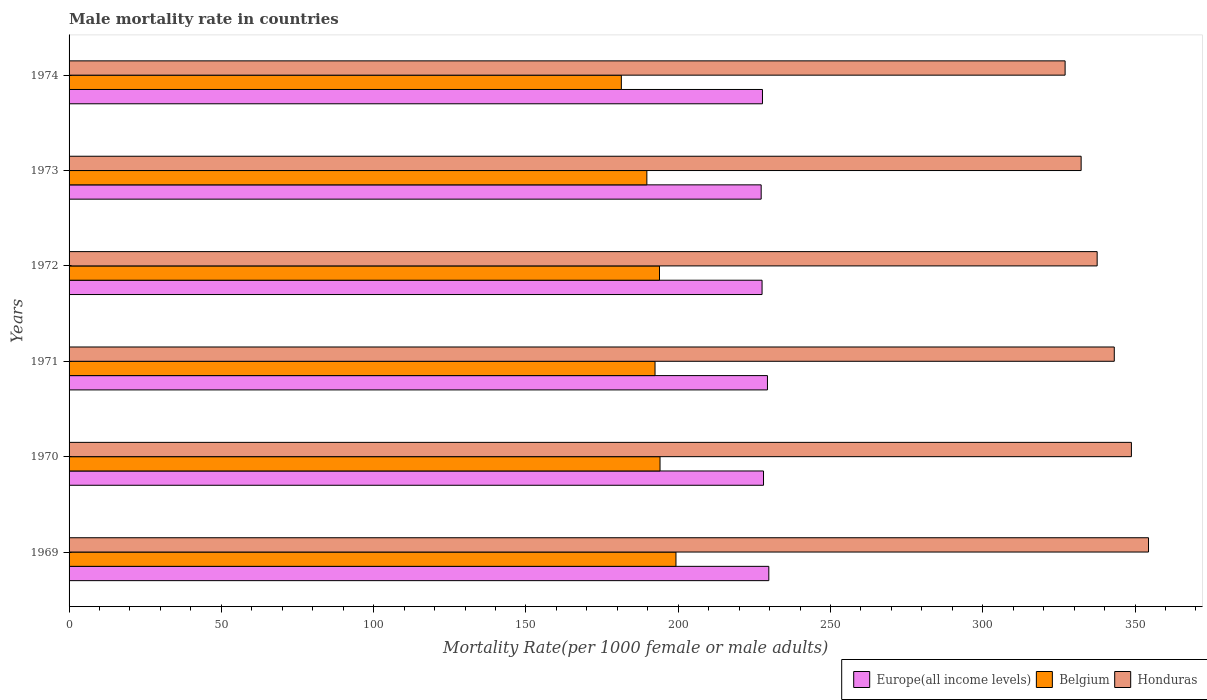How many different coloured bars are there?
Provide a succinct answer. 3. How many groups of bars are there?
Offer a terse response. 6. Are the number of bars per tick equal to the number of legend labels?
Keep it short and to the point. Yes. How many bars are there on the 6th tick from the top?
Your answer should be very brief. 3. What is the label of the 6th group of bars from the top?
Your answer should be very brief. 1969. What is the male mortality rate in Europe(all income levels) in 1969?
Provide a short and direct response. 229.76. Across all years, what is the maximum male mortality rate in Belgium?
Ensure brevity in your answer.  199.27. Across all years, what is the minimum male mortality rate in Honduras?
Provide a succinct answer. 327.04. In which year was the male mortality rate in Honduras maximum?
Ensure brevity in your answer.  1969. In which year was the male mortality rate in Europe(all income levels) minimum?
Your response must be concise. 1973. What is the total male mortality rate in Honduras in the graph?
Your answer should be compact. 2043.33. What is the difference between the male mortality rate in Honduras in 1971 and that in 1972?
Keep it short and to the point. 5.62. What is the difference between the male mortality rate in Honduras in 1973 and the male mortality rate in Europe(all income levels) in 1974?
Provide a short and direct response. 104.63. What is the average male mortality rate in Honduras per year?
Offer a very short reply. 340.56. In the year 1974, what is the difference between the male mortality rate in Europe(all income levels) and male mortality rate in Belgium?
Your answer should be very brief. 46.34. In how many years, is the male mortality rate in Europe(all income levels) greater than 60 ?
Offer a very short reply. 6. What is the ratio of the male mortality rate in Honduras in 1970 to that in 1973?
Your answer should be compact. 1.05. Is the difference between the male mortality rate in Europe(all income levels) in 1971 and 1974 greater than the difference between the male mortality rate in Belgium in 1971 and 1974?
Your answer should be very brief. No. What is the difference between the highest and the second highest male mortality rate in Honduras?
Give a very brief answer. 5.62. What is the difference between the highest and the lowest male mortality rate in Honduras?
Your answer should be compact. 27.39. What does the 2nd bar from the top in 1974 represents?
Your response must be concise. Belgium. What does the 1st bar from the bottom in 1974 represents?
Give a very brief answer. Europe(all income levels). What is the difference between two consecutive major ticks on the X-axis?
Provide a succinct answer. 50. Does the graph contain any zero values?
Provide a short and direct response. No. Where does the legend appear in the graph?
Offer a terse response. Bottom right. How are the legend labels stacked?
Your response must be concise. Horizontal. What is the title of the graph?
Make the answer very short. Male mortality rate in countries. What is the label or title of the X-axis?
Ensure brevity in your answer.  Mortality Rate(per 1000 female or male adults). What is the Mortality Rate(per 1000 female or male adults) in Europe(all income levels) in 1969?
Provide a succinct answer. 229.76. What is the Mortality Rate(per 1000 female or male adults) of Belgium in 1969?
Your answer should be compact. 199.27. What is the Mortality Rate(per 1000 female or male adults) of Honduras in 1969?
Ensure brevity in your answer.  354.43. What is the Mortality Rate(per 1000 female or male adults) in Europe(all income levels) in 1970?
Make the answer very short. 228.01. What is the Mortality Rate(per 1000 female or male adults) in Belgium in 1970?
Ensure brevity in your answer.  194.03. What is the Mortality Rate(per 1000 female or male adults) of Honduras in 1970?
Offer a terse response. 348.81. What is the Mortality Rate(per 1000 female or male adults) in Europe(all income levels) in 1971?
Ensure brevity in your answer.  229.31. What is the Mortality Rate(per 1000 female or male adults) of Belgium in 1971?
Your answer should be very brief. 192.4. What is the Mortality Rate(per 1000 female or male adults) in Honduras in 1971?
Ensure brevity in your answer.  343.19. What is the Mortality Rate(per 1000 female or male adults) in Europe(all income levels) in 1972?
Give a very brief answer. 227.54. What is the Mortality Rate(per 1000 female or male adults) of Belgium in 1972?
Make the answer very short. 193.86. What is the Mortality Rate(per 1000 female or male adults) of Honduras in 1972?
Offer a terse response. 337.57. What is the Mortality Rate(per 1000 female or male adults) in Europe(all income levels) in 1973?
Offer a terse response. 227.24. What is the Mortality Rate(per 1000 female or male adults) of Belgium in 1973?
Give a very brief answer. 189.71. What is the Mortality Rate(per 1000 female or male adults) of Honduras in 1973?
Keep it short and to the point. 332.3. What is the Mortality Rate(per 1000 female or male adults) in Europe(all income levels) in 1974?
Make the answer very short. 227.67. What is the Mortality Rate(per 1000 female or male adults) in Belgium in 1974?
Make the answer very short. 181.34. What is the Mortality Rate(per 1000 female or male adults) in Honduras in 1974?
Your answer should be very brief. 327.04. Across all years, what is the maximum Mortality Rate(per 1000 female or male adults) of Europe(all income levels)?
Give a very brief answer. 229.76. Across all years, what is the maximum Mortality Rate(per 1000 female or male adults) in Belgium?
Provide a succinct answer. 199.27. Across all years, what is the maximum Mortality Rate(per 1000 female or male adults) in Honduras?
Your answer should be compact. 354.43. Across all years, what is the minimum Mortality Rate(per 1000 female or male adults) in Europe(all income levels)?
Ensure brevity in your answer.  227.24. Across all years, what is the minimum Mortality Rate(per 1000 female or male adults) of Belgium?
Give a very brief answer. 181.34. Across all years, what is the minimum Mortality Rate(per 1000 female or male adults) of Honduras?
Give a very brief answer. 327.04. What is the total Mortality Rate(per 1000 female or male adults) in Europe(all income levels) in the graph?
Keep it short and to the point. 1369.53. What is the total Mortality Rate(per 1000 female or male adults) in Belgium in the graph?
Provide a short and direct response. 1150.61. What is the total Mortality Rate(per 1000 female or male adults) in Honduras in the graph?
Your answer should be compact. 2043.33. What is the difference between the Mortality Rate(per 1000 female or male adults) in Europe(all income levels) in 1969 and that in 1970?
Keep it short and to the point. 1.74. What is the difference between the Mortality Rate(per 1000 female or male adults) of Belgium in 1969 and that in 1970?
Give a very brief answer. 5.24. What is the difference between the Mortality Rate(per 1000 female or male adults) in Honduras in 1969 and that in 1970?
Ensure brevity in your answer.  5.62. What is the difference between the Mortality Rate(per 1000 female or male adults) in Europe(all income levels) in 1969 and that in 1971?
Ensure brevity in your answer.  0.45. What is the difference between the Mortality Rate(per 1000 female or male adults) in Belgium in 1969 and that in 1971?
Make the answer very short. 6.88. What is the difference between the Mortality Rate(per 1000 female or male adults) in Honduras in 1969 and that in 1971?
Make the answer very short. 11.24. What is the difference between the Mortality Rate(per 1000 female or male adults) in Europe(all income levels) in 1969 and that in 1972?
Offer a terse response. 2.22. What is the difference between the Mortality Rate(per 1000 female or male adults) of Belgium in 1969 and that in 1972?
Offer a terse response. 5.41. What is the difference between the Mortality Rate(per 1000 female or male adults) of Honduras in 1969 and that in 1972?
Give a very brief answer. 16.86. What is the difference between the Mortality Rate(per 1000 female or male adults) in Europe(all income levels) in 1969 and that in 1973?
Ensure brevity in your answer.  2.51. What is the difference between the Mortality Rate(per 1000 female or male adults) of Belgium in 1969 and that in 1973?
Your answer should be compact. 9.56. What is the difference between the Mortality Rate(per 1000 female or male adults) in Honduras in 1969 and that in 1973?
Your answer should be compact. 22.13. What is the difference between the Mortality Rate(per 1000 female or male adults) of Europe(all income levels) in 1969 and that in 1974?
Your answer should be very brief. 2.08. What is the difference between the Mortality Rate(per 1000 female or male adults) in Belgium in 1969 and that in 1974?
Ensure brevity in your answer.  17.93. What is the difference between the Mortality Rate(per 1000 female or male adults) of Honduras in 1969 and that in 1974?
Your response must be concise. 27.39. What is the difference between the Mortality Rate(per 1000 female or male adults) in Europe(all income levels) in 1970 and that in 1971?
Keep it short and to the point. -1.29. What is the difference between the Mortality Rate(per 1000 female or male adults) in Belgium in 1970 and that in 1971?
Give a very brief answer. 1.64. What is the difference between the Mortality Rate(per 1000 female or male adults) in Honduras in 1970 and that in 1971?
Keep it short and to the point. 5.62. What is the difference between the Mortality Rate(per 1000 female or male adults) in Europe(all income levels) in 1970 and that in 1972?
Ensure brevity in your answer.  0.47. What is the difference between the Mortality Rate(per 1000 female or male adults) of Belgium in 1970 and that in 1972?
Offer a very short reply. 0.17. What is the difference between the Mortality Rate(per 1000 female or male adults) of Honduras in 1970 and that in 1972?
Make the answer very short. 11.24. What is the difference between the Mortality Rate(per 1000 female or male adults) of Europe(all income levels) in 1970 and that in 1973?
Your answer should be very brief. 0.77. What is the difference between the Mortality Rate(per 1000 female or male adults) in Belgium in 1970 and that in 1973?
Provide a succinct answer. 4.32. What is the difference between the Mortality Rate(per 1000 female or male adults) of Honduras in 1970 and that in 1973?
Ensure brevity in your answer.  16.5. What is the difference between the Mortality Rate(per 1000 female or male adults) in Europe(all income levels) in 1970 and that in 1974?
Make the answer very short. 0.34. What is the difference between the Mortality Rate(per 1000 female or male adults) of Belgium in 1970 and that in 1974?
Offer a very short reply. 12.7. What is the difference between the Mortality Rate(per 1000 female or male adults) of Honduras in 1970 and that in 1974?
Provide a short and direct response. 21.77. What is the difference between the Mortality Rate(per 1000 female or male adults) of Europe(all income levels) in 1971 and that in 1972?
Your answer should be compact. 1.77. What is the difference between the Mortality Rate(per 1000 female or male adults) in Belgium in 1971 and that in 1972?
Ensure brevity in your answer.  -1.47. What is the difference between the Mortality Rate(per 1000 female or male adults) in Honduras in 1971 and that in 1972?
Offer a terse response. 5.62. What is the difference between the Mortality Rate(per 1000 female or male adults) in Europe(all income levels) in 1971 and that in 1973?
Your answer should be very brief. 2.06. What is the difference between the Mortality Rate(per 1000 female or male adults) of Belgium in 1971 and that in 1973?
Ensure brevity in your answer.  2.68. What is the difference between the Mortality Rate(per 1000 female or male adults) of Honduras in 1971 and that in 1973?
Your answer should be very brief. 10.88. What is the difference between the Mortality Rate(per 1000 female or male adults) of Europe(all income levels) in 1971 and that in 1974?
Offer a terse response. 1.63. What is the difference between the Mortality Rate(per 1000 female or male adults) of Belgium in 1971 and that in 1974?
Keep it short and to the point. 11.06. What is the difference between the Mortality Rate(per 1000 female or male adults) in Honduras in 1971 and that in 1974?
Your response must be concise. 16.15. What is the difference between the Mortality Rate(per 1000 female or male adults) of Europe(all income levels) in 1972 and that in 1973?
Your answer should be very brief. 0.3. What is the difference between the Mortality Rate(per 1000 female or male adults) in Belgium in 1972 and that in 1973?
Give a very brief answer. 4.15. What is the difference between the Mortality Rate(per 1000 female or male adults) in Honduras in 1972 and that in 1973?
Provide a succinct answer. 5.26. What is the difference between the Mortality Rate(per 1000 female or male adults) of Europe(all income levels) in 1972 and that in 1974?
Offer a very short reply. -0.13. What is the difference between the Mortality Rate(per 1000 female or male adults) of Belgium in 1972 and that in 1974?
Offer a very short reply. 12.52. What is the difference between the Mortality Rate(per 1000 female or male adults) in Honduras in 1972 and that in 1974?
Provide a succinct answer. 10.53. What is the difference between the Mortality Rate(per 1000 female or male adults) of Europe(all income levels) in 1973 and that in 1974?
Ensure brevity in your answer.  -0.43. What is the difference between the Mortality Rate(per 1000 female or male adults) in Belgium in 1973 and that in 1974?
Give a very brief answer. 8.38. What is the difference between the Mortality Rate(per 1000 female or male adults) of Honduras in 1973 and that in 1974?
Keep it short and to the point. 5.26. What is the difference between the Mortality Rate(per 1000 female or male adults) in Europe(all income levels) in 1969 and the Mortality Rate(per 1000 female or male adults) in Belgium in 1970?
Provide a short and direct response. 35.72. What is the difference between the Mortality Rate(per 1000 female or male adults) of Europe(all income levels) in 1969 and the Mortality Rate(per 1000 female or male adults) of Honduras in 1970?
Ensure brevity in your answer.  -119.05. What is the difference between the Mortality Rate(per 1000 female or male adults) of Belgium in 1969 and the Mortality Rate(per 1000 female or male adults) of Honduras in 1970?
Offer a terse response. -149.54. What is the difference between the Mortality Rate(per 1000 female or male adults) in Europe(all income levels) in 1969 and the Mortality Rate(per 1000 female or male adults) in Belgium in 1971?
Keep it short and to the point. 37.36. What is the difference between the Mortality Rate(per 1000 female or male adults) of Europe(all income levels) in 1969 and the Mortality Rate(per 1000 female or male adults) of Honduras in 1971?
Offer a terse response. -113.43. What is the difference between the Mortality Rate(per 1000 female or male adults) of Belgium in 1969 and the Mortality Rate(per 1000 female or male adults) of Honduras in 1971?
Provide a short and direct response. -143.92. What is the difference between the Mortality Rate(per 1000 female or male adults) in Europe(all income levels) in 1969 and the Mortality Rate(per 1000 female or male adults) in Belgium in 1972?
Keep it short and to the point. 35.89. What is the difference between the Mortality Rate(per 1000 female or male adults) of Europe(all income levels) in 1969 and the Mortality Rate(per 1000 female or male adults) of Honduras in 1972?
Provide a short and direct response. -107.81. What is the difference between the Mortality Rate(per 1000 female or male adults) of Belgium in 1969 and the Mortality Rate(per 1000 female or male adults) of Honduras in 1972?
Your response must be concise. -138.29. What is the difference between the Mortality Rate(per 1000 female or male adults) of Europe(all income levels) in 1969 and the Mortality Rate(per 1000 female or male adults) of Belgium in 1973?
Your answer should be very brief. 40.04. What is the difference between the Mortality Rate(per 1000 female or male adults) of Europe(all income levels) in 1969 and the Mortality Rate(per 1000 female or male adults) of Honduras in 1973?
Provide a short and direct response. -102.55. What is the difference between the Mortality Rate(per 1000 female or male adults) of Belgium in 1969 and the Mortality Rate(per 1000 female or male adults) of Honduras in 1973?
Provide a short and direct response. -133.03. What is the difference between the Mortality Rate(per 1000 female or male adults) in Europe(all income levels) in 1969 and the Mortality Rate(per 1000 female or male adults) in Belgium in 1974?
Offer a terse response. 48.42. What is the difference between the Mortality Rate(per 1000 female or male adults) in Europe(all income levels) in 1969 and the Mortality Rate(per 1000 female or male adults) in Honduras in 1974?
Provide a short and direct response. -97.29. What is the difference between the Mortality Rate(per 1000 female or male adults) of Belgium in 1969 and the Mortality Rate(per 1000 female or male adults) of Honduras in 1974?
Your answer should be compact. -127.77. What is the difference between the Mortality Rate(per 1000 female or male adults) of Europe(all income levels) in 1970 and the Mortality Rate(per 1000 female or male adults) of Belgium in 1971?
Offer a terse response. 35.62. What is the difference between the Mortality Rate(per 1000 female or male adults) of Europe(all income levels) in 1970 and the Mortality Rate(per 1000 female or male adults) of Honduras in 1971?
Ensure brevity in your answer.  -115.17. What is the difference between the Mortality Rate(per 1000 female or male adults) in Belgium in 1970 and the Mortality Rate(per 1000 female or male adults) in Honduras in 1971?
Give a very brief answer. -149.15. What is the difference between the Mortality Rate(per 1000 female or male adults) of Europe(all income levels) in 1970 and the Mortality Rate(per 1000 female or male adults) of Belgium in 1972?
Provide a succinct answer. 34.15. What is the difference between the Mortality Rate(per 1000 female or male adults) in Europe(all income levels) in 1970 and the Mortality Rate(per 1000 female or male adults) in Honduras in 1972?
Make the answer very short. -109.55. What is the difference between the Mortality Rate(per 1000 female or male adults) of Belgium in 1970 and the Mortality Rate(per 1000 female or male adults) of Honduras in 1972?
Provide a succinct answer. -143.53. What is the difference between the Mortality Rate(per 1000 female or male adults) of Europe(all income levels) in 1970 and the Mortality Rate(per 1000 female or male adults) of Belgium in 1973?
Ensure brevity in your answer.  38.3. What is the difference between the Mortality Rate(per 1000 female or male adults) in Europe(all income levels) in 1970 and the Mortality Rate(per 1000 female or male adults) in Honduras in 1973?
Offer a very short reply. -104.29. What is the difference between the Mortality Rate(per 1000 female or male adults) of Belgium in 1970 and the Mortality Rate(per 1000 female or male adults) of Honduras in 1973?
Provide a succinct answer. -138.27. What is the difference between the Mortality Rate(per 1000 female or male adults) in Europe(all income levels) in 1970 and the Mortality Rate(per 1000 female or male adults) in Belgium in 1974?
Provide a short and direct response. 46.68. What is the difference between the Mortality Rate(per 1000 female or male adults) in Europe(all income levels) in 1970 and the Mortality Rate(per 1000 female or male adults) in Honduras in 1974?
Your response must be concise. -99.03. What is the difference between the Mortality Rate(per 1000 female or male adults) in Belgium in 1970 and the Mortality Rate(per 1000 female or male adults) in Honduras in 1974?
Your answer should be very brief. -133.01. What is the difference between the Mortality Rate(per 1000 female or male adults) of Europe(all income levels) in 1971 and the Mortality Rate(per 1000 female or male adults) of Belgium in 1972?
Make the answer very short. 35.45. What is the difference between the Mortality Rate(per 1000 female or male adults) in Europe(all income levels) in 1971 and the Mortality Rate(per 1000 female or male adults) in Honduras in 1972?
Provide a short and direct response. -108.26. What is the difference between the Mortality Rate(per 1000 female or male adults) of Belgium in 1971 and the Mortality Rate(per 1000 female or male adults) of Honduras in 1972?
Keep it short and to the point. -145.17. What is the difference between the Mortality Rate(per 1000 female or male adults) in Europe(all income levels) in 1971 and the Mortality Rate(per 1000 female or male adults) in Belgium in 1973?
Provide a short and direct response. 39.6. What is the difference between the Mortality Rate(per 1000 female or male adults) of Europe(all income levels) in 1971 and the Mortality Rate(per 1000 female or male adults) of Honduras in 1973?
Make the answer very short. -103. What is the difference between the Mortality Rate(per 1000 female or male adults) of Belgium in 1971 and the Mortality Rate(per 1000 female or male adults) of Honduras in 1973?
Your answer should be very brief. -139.91. What is the difference between the Mortality Rate(per 1000 female or male adults) of Europe(all income levels) in 1971 and the Mortality Rate(per 1000 female or male adults) of Belgium in 1974?
Your answer should be very brief. 47.97. What is the difference between the Mortality Rate(per 1000 female or male adults) of Europe(all income levels) in 1971 and the Mortality Rate(per 1000 female or male adults) of Honduras in 1974?
Keep it short and to the point. -97.73. What is the difference between the Mortality Rate(per 1000 female or male adults) in Belgium in 1971 and the Mortality Rate(per 1000 female or male adults) in Honduras in 1974?
Provide a short and direct response. -134.65. What is the difference between the Mortality Rate(per 1000 female or male adults) of Europe(all income levels) in 1972 and the Mortality Rate(per 1000 female or male adults) of Belgium in 1973?
Ensure brevity in your answer.  37.83. What is the difference between the Mortality Rate(per 1000 female or male adults) in Europe(all income levels) in 1972 and the Mortality Rate(per 1000 female or male adults) in Honduras in 1973?
Provide a succinct answer. -104.76. What is the difference between the Mortality Rate(per 1000 female or male adults) in Belgium in 1972 and the Mortality Rate(per 1000 female or male adults) in Honduras in 1973?
Your answer should be compact. -138.44. What is the difference between the Mortality Rate(per 1000 female or male adults) in Europe(all income levels) in 1972 and the Mortality Rate(per 1000 female or male adults) in Belgium in 1974?
Give a very brief answer. 46.2. What is the difference between the Mortality Rate(per 1000 female or male adults) in Europe(all income levels) in 1972 and the Mortality Rate(per 1000 female or male adults) in Honduras in 1974?
Your answer should be very brief. -99.5. What is the difference between the Mortality Rate(per 1000 female or male adults) of Belgium in 1972 and the Mortality Rate(per 1000 female or male adults) of Honduras in 1974?
Provide a succinct answer. -133.18. What is the difference between the Mortality Rate(per 1000 female or male adults) in Europe(all income levels) in 1973 and the Mortality Rate(per 1000 female or male adults) in Belgium in 1974?
Keep it short and to the point. 45.91. What is the difference between the Mortality Rate(per 1000 female or male adults) in Europe(all income levels) in 1973 and the Mortality Rate(per 1000 female or male adults) in Honduras in 1974?
Keep it short and to the point. -99.8. What is the difference between the Mortality Rate(per 1000 female or male adults) in Belgium in 1973 and the Mortality Rate(per 1000 female or male adults) in Honduras in 1974?
Offer a very short reply. -137.33. What is the average Mortality Rate(per 1000 female or male adults) in Europe(all income levels) per year?
Provide a succinct answer. 228.26. What is the average Mortality Rate(per 1000 female or male adults) of Belgium per year?
Offer a terse response. 191.77. What is the average Mortality Rate(per 1000 female or male adults) of Honduras per year?
Your answer should be compact. 340.56. In the year 1969, what is the difference between the Mortality Rate(per 1000 female or male adults) in Europe(all income levels) and Mortality Rate(per 1000 female or male adults) in Belgium?
Provide a short and direct response. 30.48. In the year 1969, what is the difference between the Mortality Rate(per 1000 female or male adults) in Europe(all income levels) and Mortality Rate(per 1000 female or male adults) in Honduras?
Offer a terse response. -124.67. In the year 1969, what is the difference between the Mortality Rate(per 1000 female or male adults) of Belgium and Mortality Rate(per 1000 female or male adults) of Honduras?
Ensure brevity in your answer.  -155.16. In the year 1970, what is the difference between the Mortality Rate(per 1000 female or male adults) of Europe(all income levels) and Mortality Rate(per 1000 female or male adults) of Belgium?
Give a very brief answer. 33.98. In the year 1970, what is the difference between the Mortality Rate(per 1000 female or male adults) in Europe(all income levels) and Mortality Rate(per 1000 female or male adults) in Honduras?
Offer a very short reply. -120.79. In the year 1970, what is the difference between the Mortality Rate(per 1000 female or male adults) of Belgium and Mortality Rate(per 1000 female or male adults) of Honduras?
Provide a short and direct response. -154.77. In the year 1971, what is the difference between the Mortality Rate(per 1000 female or male adults) in Europe(all income levels) and Mortality Rate(per 1000 female or male adults) in Belgium?
Keep it short and to the point. 36.91. In the year 1971, what is the difference between the Mortality Rate(per 1000 female or male adults) in Europe(all income levels) and Mortality Rate(per 1000 female or male adults) in Honduras?
Your answer should be very brief. -113.88. In the year 1971, what is the difference between the Mortality Rate(per 1000 female or male adults) in Belgium and Mortality Rate(per 1000 female or male adults) in Honduras?
Give a very brief answer. -150.79. In the year 1972, what is the difference between the Mortality Rate(per 1000 female or male adults) of Europe(all income levels) and Mortality Rate(per 1000 female or male adults) of Belgium?
Ensure brevity in your answer.  33.68. In the year 1972, what is the difference between the Mortality Rate(per 1000 female or male adults) in Europe(all income levels) and Mortality Rate(per 1000 female or male adults) in Honduras?
Make the answer very short. -110.03. In the year 1972, what is the difference between the Mortality Rate(per 1000 female or male adults) of Belgium and Mortality Rate(per 1000 female or male adults) of Honduras?
Your answer should be very brief. -143.71. In the year 1973, what is the difference between the Mortality Rate(per 1000 female or male adults) in Europe(all income levels) and Mortality Rate(per 1000 female or male adults) in Belgium?
Offer a very short reply. 37.53. In the year 1973, what is the difference between the Mortality Rate(per 1000 female or male adults) in Europe(all income levels) and Mortality Rate(per 1000 female or male adults) in Honduras?
Offer a very short reply. -105.06. In the year 1973, what is the difference between the Mortality Rate(per 1000 female or male adults) in Belgium and Mortality Rate(per 1000 female or male adults) in Honduras?
Your answer should be compact. -142.59. In the year 1974, what is the difference between the Mortality Rate(per 1000 female or male adults) in Europe(all income levels) and Mortality Rate(per 1000 female or male adults) in Belgium?
Offer a terse response. 46.34. In the year 1974, what is the difference between the Mortality Rate(per 1000 female or male adults) of Europe(all income levels) and Mortality Rate(per 1000 female or male adults) of Honduras?
Your answer should be compact. -99.37. In the year 1974, what is the difference between the Mortality Rate(per 1000 female or male adults) of Belgium and Mortality Rate(per 1000 female or male adults) of Honduras?
Keep it short and to the point. -145.7. What is the ratio of the Mortality Rate(per 1000 female or male adults) in Europe(all income levels) in 1969 to that in 1970?
Your answer should be very brief. 1.01. What is the ratio of the Mortality Rate(per 1000 female or male adults) in Belgium in 1969 to that in 1970?
Keep it short and to the point. 1.03. What is the ratio of the Mortality Rate(per 1000 female or male adults) in Honduras in 1969 to that in 1970?
Your response must be concise. 1.02. What is the ratio of the Mortality Rate(per 1000 female or male adults) of Belgium in 1969 to that in 1971?
Provide a short and direct response. 1.04. What is the ratio of the Mortality Rate(per 1000 female or male adults) in Honduras in 1969 to that in 1971?
Your answer should be compact. 1.03. What is the ratio of the Mortality Rate(per 1000 female or male adults) in Europe(all income levels) in 1969 to that in 1972?
Make the answer very short. 1.01. What is the ratio of the Mortality Rate(per 1000 female or male adults) of Belgium in 1969 to that in 1972?
Keep it short and to the point. 1.03. What is the ratio of the Mortality Rate(per 1000 female or male adults) of Honduras in 1969 to that in 1972?
Give a very brief answer. 1.05. What is the ratio of the Mortality Rate(per 1000 female or male adults) in Europe(all income levels) in 1969 to that in 1973?
Your response must be concise. 1.01. What is the ratio of the Mortality Rate(per 1000 female or male adults) in Belgium in 1969 to that in 1973?
Offer a terse response. 1.05. What is the ratio of the Mortality Rate(per 1000 female or male adults) of Honduras in 1969 to that in 1973?
Offer a very short reply. 1.07. What is the ratio of the Mortality Rate(per 1000 female or male adults) of Europe(all income levels) in 1969 to that in 1974?
Your answer should be very brief. 1.01. What is the ratio of the Mortality Rate(per 1000 female or male adults) in Belgium in 1969 to that in 1974?
Make the answer very short. 1.1. What is the ratio of the Mortality Rate(per 1000 female or male adults) in Honduras in 1969 to that in 1974?
Your answer should be very brief. 1.08. What is the ratio of the Mortality Rate(per 1000 female or male adults) of Europe(all income levels) in 1970 to that in 1971?
Provide a succinct answer. 0.99. What is the ratio of the Mortality Rate(per 1000 female or male adults) of Belgium in 1970 to that in 1971?
Offer a terse response. 1.01. What is the ratio of the Mortality Rate(per 1000 female or male adults) of Honduras in 1970 to that in 1971?
Your answer should be very brief. 1.02. What is the ratio of the Mortality Rate(per 1000 female or male adults) of Europe(all income levels) in 1970 to that in 1972?
Your answer should be compact. 1. What is the ratio of the Mortality Rate(per 1000 female or male adults) in Belgium in 1970 to that in 1972?
Give a very brief answer. 1. What is the ratio of the Mortality Rate(per 1000 female or male adults) of Europe(all income levels) in 1970 to that in 1973?
Offer a very short reply. 1. What is the ratio of the Mortality Rate(per 1000 female or male adults) of Belgium in 1970 to that in 1973?
Provide a succinct answer. 1.02. What is the ratio of the Mortality Rate(per 1000 female or male adults) in Honduras in 1970 to that in 1973?
Offer a terse response. 1.05. What is the ratio of the Mortality Rate(per 1000 female or male adults) of Belgium in 1970 to that in 1974?
Your response must be concise. 1.07. What is the ratio of the Mortality Rate(per 1000 female or male adults) of Honduras in 1970 to that in 1974?
Give a very brief answer. 1.07. What is the ratio of the Mortality Rate(per 1000 female or male adults) in Europe(all income levels) in 1971 to that in 1972?
Give a very brief answer. 1.01. What is the ratio of the Mortality Rate(per 1000 female or male adults) in Honduras in 1971 to that in 1972?
Your answer should be compact. 1.02. What is the ratio of the Mortality Rate(per 1000 female or male adults) in Europe(all income levels) in 1971 to that in 1973?
Provide a short and direct response. 1.01. What is the ratio of the Mortality Rate(per 1000 female or male adults) of Belgium in 1971 to that in 1973?
Provide a succinct answer. 1.01. What is the ratio of the Mortality Rate(per 1000 female or male adults) in Honduras in 1971 to that in 1973?
Ensure brevity in your answer.  1.03. What is the ratio of the Mortality Rate(per 1000 female or male adults) in Europe(all income levels) in 1971 to that in 1974?
Your response must be concise. 1.01. What is the ratio of the Mortality Rate(per 1000 female or male adults) in Belgium in 1971 to that in 1974?
Your answer should be compact. 1.06. What is the ratio of the Mortality Rate(per 1000 female or male adults) in Honduras in 1971 to that in 1974?
Make the answer very short. 1.05. What is the ratio of the Mortality Rate(per 1000 female or male adults) in Belgium in 1972 to that in 1973?
Give a very brief answer. 1.02. What is the ratio of the Mortality Rate(per 1000 female or male adults) in Honduras in 1972 to that in 1973?
Your response must be concise. 1.02. What is the ratio of the Mortality Rate(per 1000 female or male adults) in Europe(all income levels) in 1972 to that in 1974?
Your answer should be compact. 1. What is the ratio of the Mortality Rate(per 1000 female or male adults) of Belgium in 1972 to that in 1974?
Provide a short and direct response. 1.07. What is the ratio of the Mortality Rate(per 1000 female or male adults) of Honduras in 1972 to that in 1974?
Provide a succinct answer. 1.03. What is the ratio of the Mortality Rate(per 1000 female or male adults) of Europe(all income levels) in 1973 to that in 1974?
Provide a succinct answer. 1. What is the ratio of the Mortality Rate(per 1000 female or male adults) of Belgium in 1973 to that in 1974?
Offer a terse response. 1.05. What is the ratio of the Mortality Rate(per 1000 female or male adults) of Honduras in 1973 to that in 1974?
Provide a short and direct response. 1.02. What is the difference between the highest and the second highest Mortality Rate(per 1000 female or male adults) of Europe(all income levels)?
Offer a very short reply. 0.45. What is the difference between the highest and the second highest Mortality Rate(per 1000 female or male adults) in Belgium?
Ensure brevity in your answer.  5.24. What is the difference between the highest and the second highest Mortality Rate(per 1000 female or male adults) of Honduras?
Provide a short and direct response. 5.62. What is the difference between the highest and the lowest Mortality Rate(per 1000 female or male adults) in Europe(all income levels)?
Your answer should be very brief. 2.51. What is the difference between the highest and the lowest Mortality Rate(per 1000 female or male adults) in Belgium?
Your response must be concise. 17.93. What is the difference between the highest and the lowest Mortality Rate(per 1000 female or male adults) in Honduras?
Your answer should be very brief. 27.39. 